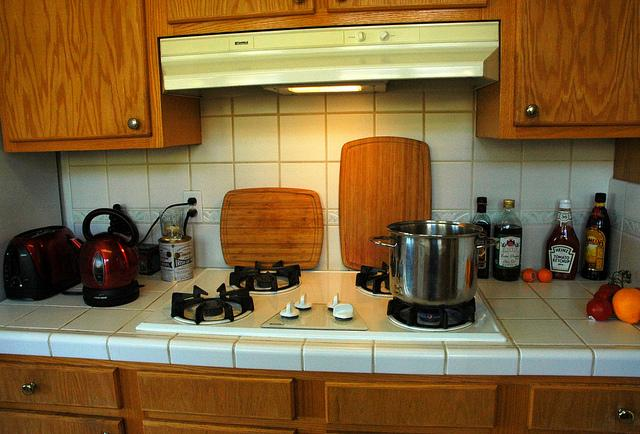What is a favorite condiment of the owner? Please explain your reasoning. ketchup. There is a bottle of ketchup on the counter. 